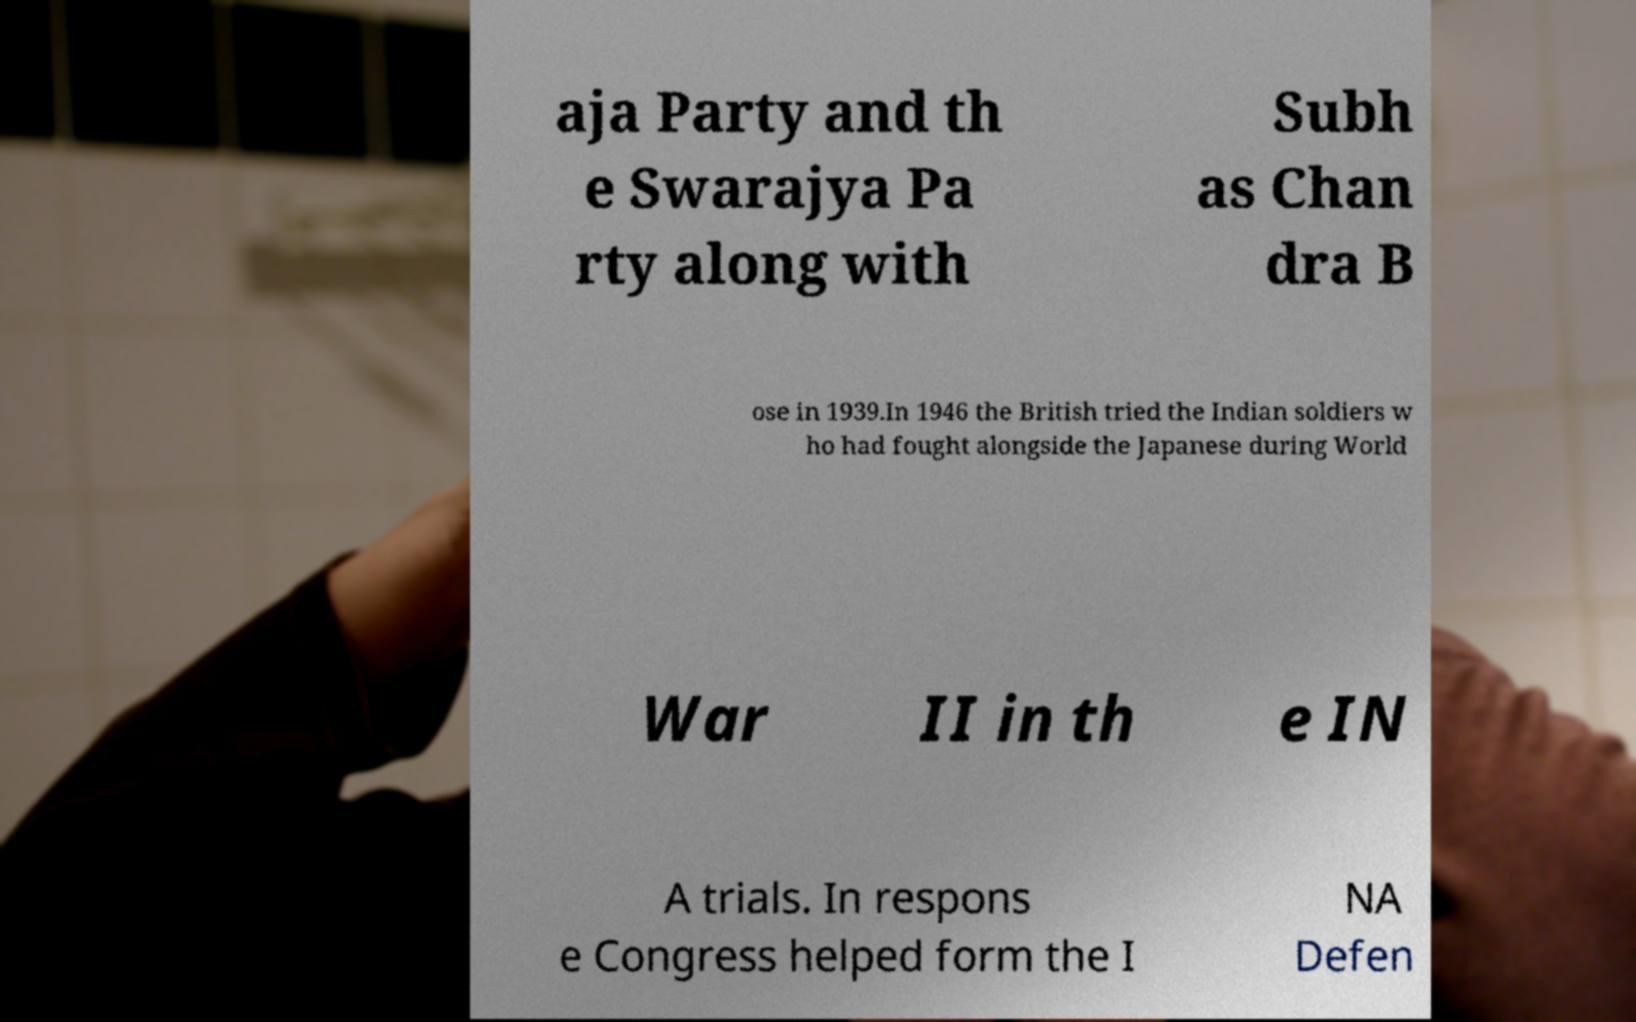Can you accurately transcribe the text from the provided image for me? aja Party and th e Swarajya Pa rty along with Subh as Chan dra B ose in 1939.In 1946 the British tried the Indian soldiers w ho had fought alongside the Japanese during World War II in th e IN A trials. In respons e Congress helped form the I NA Defen 